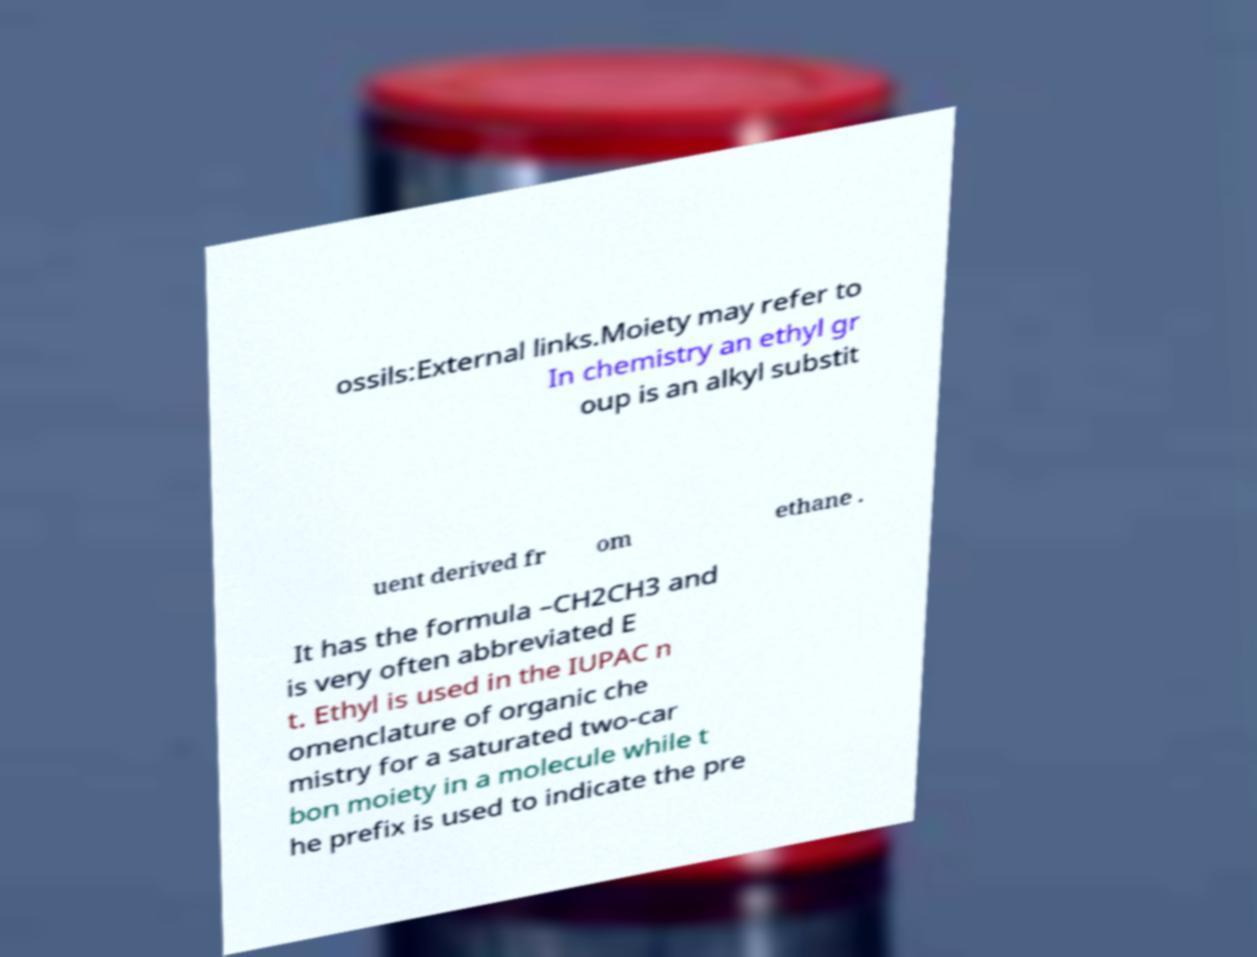Could you extract and type out the text from this image? ossils:External links.Moiety may refer to In chemistry an ethyl gr oup is an alkyl substit uent derived fr om ethane . It has the formula –CH2CH3 and is very often abbreviated E t. Ethyl is used in the IUPAC n omenclature of organic che mistry for a saturated two-car bon moiety in a molecule while t he prefix is used to indicate the pre 